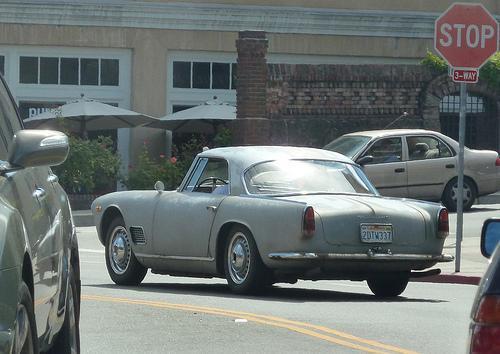How many cars are there?
Give a very brief answer. 4. 